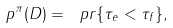<formula> <loc_0><loc_0><loc_500><loc_500>p ^ { \pi } ( D ) = \ p r \{ \tau _ { e } < \tau _ { f } \} ,</formula> 